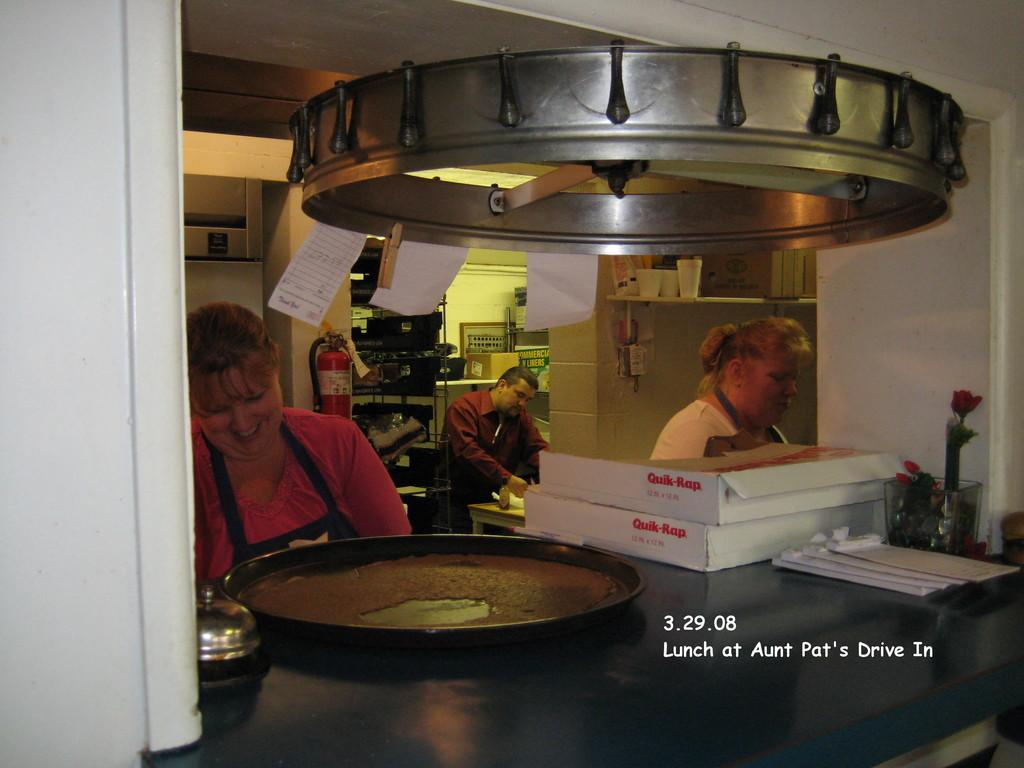<image>
Render a clear and concise summary of the photo. Two workers behind the counter at Aunt Pat's Drive Inn. 